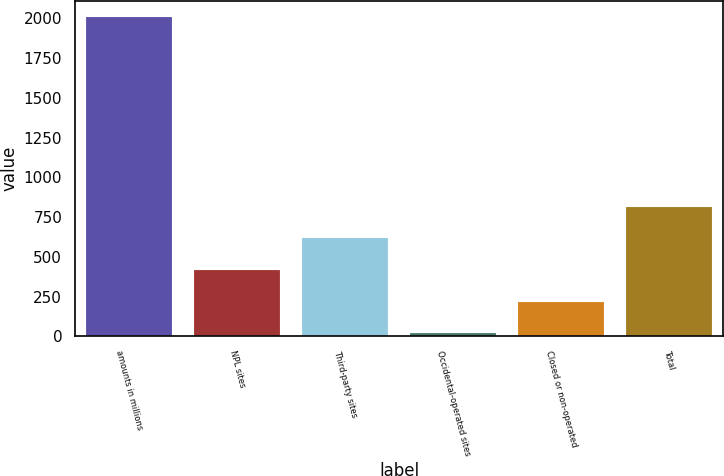Convert chart to OTSL. <chart><loc_0><loc_0><loc_500><loc_500><bar_chart><fcel>amounts in millions<fcel>NPL sites<fcel>Third-party sites<fcel>Occidental-operated sites<fcel>Closed or non-operated<fcel>Total<nl><fcel>2010<fcel>418<fcel>617<fcel>20<fcel>219<fcel>816<nl></chart> 